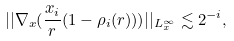Convert formula to latex. <formula><loc_0><loc_0><loc_500><loc_500>| | \nabla _ { x } ( \frac { x _ { i } } { r } ( 1 - \rho _ { i } ( r ) ) ) | | _ { L _ { x } ^ { \infty } } \lesssim 2 ^ { - i } ,</formula> 